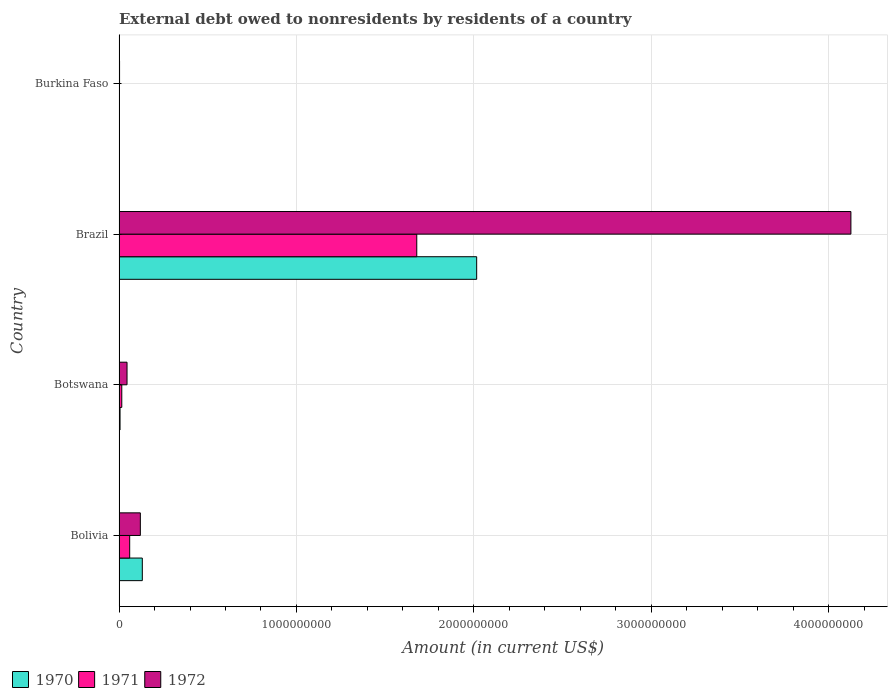How many different coloured bars are there?
Offer a very short reply. 3. Are the number of bars on each tick of the Y-axis equal?
Give a very brief answer. Yes. How many bars are there on the 3rd tick from the bottom?
Give a very brief answer. 3. What is the label of the 4th group of bars from the top?
Give a very brief answer. Bolivia. What is the external debt owed by residents in 1970 in Bolivia?
Provide a succinct answer. 1.31e+08. Across all countries, what is the maximum external debt owed by residents in 1970?
Keep it short and to the point. 2.02e+09. Across all countries, what is the minimum external debt owed by residents in 1971?
Offer a terse response. 1.32e+06. In which country was the external debt owed by residents in 1971 maximum?
Make the answer very short. Brazil. In which country was the external debt owed by residents in 1970 minimum?
Give a very brief answer. Burkina Faso. What is the total external debt owed by residents in 1972 in the graph?
Offer a terse response. 4.29e+09. What is the difference between the external debt owed by residents in 1970 in Bolivia and that in Burkina Faso?
Your answer should be compact. 1.30e+08. What is the difference between the external debt owed by residents in 1971 in Bolivia and the external debt owed by residents in 1972 in Botswana?
Provide a succinct answer. 1.50e+07. What is the average external debt owed by residents in 1972 per country?
Your answer should be compact. 1.07e+09. What is the difference between the external debt owed by residents in 1970 and external debt owed by residents in 1971 in Burkina Faso?
Offer a terse response. -6.68e+05. What is the ratio of the external debt owed by residents in 1971 in Botswana to that in Burkina Faso?
Ensure brevity in your answer.  11.67. Is the difference between the external debt owed by residents in 1970 in Bolivia and Burkina Faso greater than the difference between the external debt owed by residents in 1971 in Bolivia and Burkina Faso?
Keep it short and to the point. Yes. What is the difference between the highest and the second highest external debt owed by residents in 1972?
Give a very brief answer. 4.00e+09. What is the difference between the highest and the lowest external debt owed by residents in 1971?
Keep it short and to the point. 1.68e+09. Is the sum of the external debt owed by residents in 1970 in Botswana and Burkina Faso greater than the maximum external debt owed by residents in 1972 across all countries?
Make the answer very short. No. What does the 1st bar from the top in Brazil represents?
Give a very brief answer. 1972. How many bars are there?
Offer a terse response. 12. What is the difference between two consecutive major ticks on the X-axis?
Give a very brief answer. 1.00e+09. Are the values on the major ticks of X-axis written in scientific E-notation?
Your answer should be very brief. No. Does the graph contain grids?
Provide a short and direct response. Yes. What is the title of the graph?
Your response must be concise. External debt owed to nonresidents by residents of a country. Does "1963" appear as one of the legend labels in the graph?
Make the answer very short. No. What is the label or title of the X-axis?
Your response must be concise. Amount (in current US$). What is the label or title of the Y-axis?
Provide a succinct answer. Country. What is the Amount (in current US$) of 1970 in Bolivia?
Keep it short and to the point. 1.31e+08. What is the Amount (in current US$) in 1971 in Bolivia?
Give a very brief answer. 5.99e+07. What is the Amount (in current US$) in 1972 in Bolivia?
Give a very brief answer. 1.20e+08. What is the Amount (in current US$) in 1970 in Botswana?
Ensure brevity in your answer.  5.57e+06. What is the Amount (in current US$) of 1971 in Botswana?
Provide a short and direct response. 1.54e+07. What is the Amount (in current US$) of 1972 in Botswana?
Keep it short and to the point. 4.50e+07. What is the Amount (in current US$) in 1970 in Brazil?
Your answer should be compact. 2.02e+09. What is the Amount (in current US$) in 1971 in Brazil?
Give a very brief answer. 1.68e+09. What is the Amount (in current US$) in 1972 in Brazil?
Your answer should be compact. 4.13e+09. What is the Amount (in current US$) of 1970 in Burkina Faso?
Offer a very short reply. 6.51e+05. What is the Amount (in current US$) of 1971 in Burkina Faso?
Provide a short and direct response. 1.32e+06. What is the Amount (in current US$) in 1972 in Burkina Faso?
Make the answer very short. 2.91e+06. Across all countries, what is the maximum Amount (in current US$) of 1970?
Provide a succinct answer. 2.02e+09. Across all countries, what is the maximum Amount (in current US$) of 1971?
Provide a short and direct response. 1.68e+09. Across all countries, what is the maximum Amount (in current US$) of 1972?
Provide a short and direct response. 4.13e+09. Across all countries, what is the minimum Amount (in current US$) in 1970?
Offer a very short reply. 6.51e+05. Across all countries, what is the minimum Amount (in current US$) of 1971?
Your response must be concise. 1.32e+06. Across all countries, what is the minimum Amount (in current US$) of 1972?
Give a very brief answer. 2.91e+06. What is the total Amount (in current US$) of 1970 in the graph?
Offer a very short reply. 2.15e+09. What is the total Amount (in current US$) of 1971 in the graph?
Your response must be concise. 1.75e+09. What is the total Amount (in current US$) of 1972 in the graph?
Keep it short and to the point. 4.29e+09. What is the difference between the Amount (in current US$) in 1970 in Bolivia and that in Botswana?
Ensure brevity in your answer.  1.26e+08. What is the difference between the Amount (in current US$) in 1971 in Bolivia and that in Botswana?
Provide a short and direct response. 4.45e+07. What is the difference between the Amount (in current US$) of 1972 in Bolivia and that in Botswana?
Ensure brevity in your answer.  7.51e+07. What is the difference between the Amount (in current US$) in 1970 in Bolivia and that in Brazil?
Ensure brevity in your answer.  -1.88e+09. What is the difference between the Amount (in current US$) of 1971 in Bolivia and that in Brazil?
Give a very brief answer. -1.62e+09. What is the difference between the Amount (in current US$) of 1972 in Bolivia and that in Brazil?
Offer a very short reply. -4.00e+09. What is the difference between the Amount (in current US$) of 1970 in Bolivia and that in Burkina Faso?
Keep it short and to the point. 1.30e+08. What is the difference between the Amount (in current US$) in 1971 in Bolivia and that in Burkina Faso?
Keep it short and to the point. 5.86e+07. What is the difference between the Amount (in current US$) of 1972 in Bolivia and that in Burkina Faso?
Provide a short and direct response. 1.17e+08. What is the difference between the Amount (in current US$) in 1970 in Botswana and that in Brazil?
Offer a terse response. -2.01e+09. What is the difference between the Amount (in current US$) of 1971 in Botswana and that in Brazil?
Make the answer very short. -1.66e+09. What is the difference between the Amount (in current US$) in 1972 in Botswana and that in Brazil?
Your answer should be compact. -4.08e+09. What is the difference between the Amount (in current US$) of 1970 in Botswana and that in Burkina Faso?
Keep it short and to the point. 4.92e+06. What is the difference between the Amount (in current US$) in 1971 in Botswana and that in Burkina Faso?
Ensure brevity in your answer.  1.41e+07. What is the difference between the Amount (in current US$) of 1972 in Botswana and that in Burkina Faso?
Keep it short and to the point. 4.20e+07. What is the difference between the Amount (in current US$) of 1970 in Brazil and that in Burkina Faso?
Provide a succinct answer. 2.02e+09. What is the difference between the Amount (in current US$) in 1971 in Brazil and that in Burkina Faso?
Provide a succinct answer. 1.68e+09. What is the difference between the Amount (in current US$) in 1972 in Brazil and that in Burkina Faso?
Provide a succinct answer. 4.12e+09. What is the difference between the Amount (in current US$) of 1970 in Bolivia and the Amount (in current US$) of 1971 in Botswana?
Your answer should be compact. 1.16e+08. What is the difference between the Amount (in current US$) of 1970 in Bolivia and the Amount (in current US$) of 1972 in Botswana?
Keep it short and to the point. 8.61e+07. What is the difference between the Amount (in current US$) of 1971 in Bolivia and the Amount (in current US$) of 1972 in Botswana?
Ensure brevity in your answer.  1.50e+07. What is the difference between the Amount (in current US$) of 1970 in Bolivia and the Amount (in current US$) of 1971 in Brazil?
Provide a succinct answer. -1.55e+09. What is the difference between the Amount (in current US$) in 1970 in Bolivia and the Amount (in current US$) in 1972 in Brazil?
Your answer should be very brief. -3.99e+09. What is the difference between the Amount (in current US$) in 1971 in Bolivia and the Amount (in current US$) in 1972 in Brazil?
Offer a very short reply. -4.07e+09. What is the difference between the Amount (in current US$) in 1970 in Bolivia and the Amount (in current US$) in 1971 in Burkina Faso?
Your answer should be compact. 1.30e+08. What is the difference between the Amount (in current US$) of 1970 in Bolivia and the Amount (in current US$) of 1972 in Burkina Faso?
Offer a very short reply. 1.28e+08. What is the difference between the Amount (in current US$) in 1971 in Bolivia and the Amount (in current US$) in 1972 in Burkina Faso?
Your response must be concise. 5.70e+07. What is the difference between the Amount (in current US$) of 1970 in Botswana and the Amount (in current US$) of 1971 in Brazil?
Your response must be concise. -1.67e+09. What is the difference between the Amount (in current US$) in 1970 in Botswana and the Amount (in current US$) in 1972 in Brazil?
Give a very brief answer. -4.12e+09. What is the difference between the Amount (in current US$) of 1971 in Botswana and the Amount (in current US$) of 1972 in Brazil?
Make the answer very short. -4.11e+09. What is the difference between the Amount (in current US$) of 1970 in Botswana and the Amount (in current US$) of 1971 in Burkina Faso?
Your answer should be compact. 4.25e+06. What is the difference between the Amount (in current US$) in 1970 in Botswana and the Amount (in current US$) in 1972 in Burkina Faso?
Your response must be concise. 2.66e+06. What is the difference between the Amount (in current US$) of 1971 in Botswana and the Amount (in current US$) of 1972 in Burkina Faso?
Ensure brevity in your answer.  1.25e+07. What is the difference between the Amount (in current US$) of 1970 in Brazil and the Amount (in current US$) of 1971 in Burkina Faso?
Provide a succinct answer. 2.01e+09. What is the difference between the Amount (in current US$) in 1970 in Brazil and the Amount (in current US$) in 1972 in Burkina Faso?
Ensure brevity in your answer.  2.01e+09. What is the difference between the Amount (in current US$) in 1971 in Brazil and the Amount (in current US$) in 1972 in Burkina Faso?
Make the answer very short. 1.68e+09. What is the average Amount (in current US$) of 1970 per country?
Make the answer very short. 5.38e+08. What is the average Amount (in current US$) in 1971 per country?
Provide a short and direct response. 4.39e+08. What is the average Amount (in current US$) of 1972 per country?
Your answer should be compact. 1.07e+09. What is the difference between the Amount (in current US$) of 1970 and Amount (in current US$) of 1971 in Bolivia?
Your response must be concise. 7.11e+07. What is the difference between the Amount (in current US$) of 1970 and Amount (in current US$) of 1972 in Bolivia?
Your answer should be very brief. 1.10e+07. What is the difference between the Amount (in current US$) of 1971 and Amount (in current US$) of 1972 in Bolivia?
Offer a very short reply. -6.01e+07. What is the difference between the Amount (in current US$) in 1970 and Amount (in current US$) in 1971 in Botswana?
Ensure brevity in your answer.  -9.82e+06. What is the difference between the Amount (in current US$) of 1970 and Amount (in current US$) of 1972 in Botswana?
Ensure brevity in your answer.  -3.94e+07. What is the difference between the Amount (in current US$) in 1971 and Amount (in current US$) in 1972 in Botswana?
Give a very brief answer. -2.96e+07. What is the difference between the Amount (in current US$) in 1970 and Amount (in current US$) in 1971 in Brazil?
Provide a succinct answer. 3.38e+08. What is the difference between the Amount (in current US$) in 1970 and Amount (in current US$) in 1972 in Brazil?
Ensure brevity in your answer.  -2.11e+09. What is the difference between the Amount (in current US$) of 1971 and Amount (in current US$) of 1972 in Brazil?
Provide a short and direct response. -2.45e+09. What is the difference between the Amount (in current US$) in 1970 and Amount (in current US$) in 1971 in Burkina Faso?
Make the answer very short. -6.68e+05. What is the difference between the Amount (in current US$) of 1970 and Amount (in current US$) of 1972 in Burkina Faso?
Your answer should be very brief. -2.26e+06. What is the difference between the Amount (in current US$) in 1971 and Amount (in current US$) in 1972 in Burkina Faso?
Your response must be concise. -1.59e+06. What is the ratio of the Amount (in current US$) of 1970 in Bolivia to that in Botswana?
Your answer should be compact. 23.55. What is the ratio of the Amount (in current US$) in 1971 in Bolivia to that in Botswana?
Offer a terse response. 3.89. What is the ratio of the Amount (in current US$) of 1972 in Bolivia to that in Botswana?
Keep it short and to the point. 2.67. What is the ratio of the Amount (in current US$) of 1970 in Bolivia to that in Brazil?
Your answer should be very brief. 0.07. What is the ratio of the Amount (in current US$) of 1971 in Bolivia to that in Brazil?
Your answer should be compact. 0.04. What is the ratio of the Amount (in current US$) of 1972 in Bolivia to that in Brazil?
Provide a succinct answer. 0.03. What is the ratio of the Amount (in current US$) of 1970 in Bolivia to that in Burkina Faso?
Offer a very short reply. 201.34. What is the ratio of the Amount (in current US$) in 1971 in Bolivia to that in Burkina Faso?
Ensure brevity in your answer.  45.43. What is the ratio of the Amount (in current US$) of 1972 in Bolivia to that in Burkina Faso?
Make the answer very short. 41.31. What is the ratio of the Amount (in current US$) of 1970 in Botswana to that in Brazil?
Offer a terse response. 0. What is the ratio of the Amount (in current US$) of 1971 in Botswana to that in Brazil?
Give a very brief answer. 0.01. What is the ratio of the Amount (in current US$) of 1972 in Botswana to that in Brazil?
Keep it short and to the point. 0.01. What is the ratio of the Amount (in current US$) in 1970 in Botswana to that in Burkina Faso?
Provide a succinct answer. 8.55. What is the ratio of the Amount (in current US$) of 1971 in Botswana to that in Burkina Faso?
Provide a succinct answer. 11.67. What is the ratio of the Amount (in current US$) of 1972 in Botswana to that in Burkina Faso?
Offer a terse response. 15.47. What is the ratio of the Amount (in current US$) of 1970 in Brazil to that in Burkina Faso?
Ensure brevity in your answer.  3096.3. What is the ratio of the Amount (in current US$) in 1971 in Brazil to that in Burkina Faso?
Your answer should be very brief. 1272.21. What is the ratio of the Amount (in current US$) of 1972 in Brazil to that in Burkina Faso?
Your answer should be very brief. 1419.49. What is the difference between the highest and the second highest Amount (in current US$) in 1970?
Offer a very short reply. 1.88e+09. What is the difference between the highest and the second highest Amount (in current US$) of 1971?
Your response must be concise. 1.62e+09. What is the difference between the highest and the second highest Amount (in current US$) in 1972?
Provide a succinct answer. 4.00e+09. What is the difference between the highest and the lowest Amount (in current US$) in 1970?
Provide a succinct answer. 2.02e+09. What is the difference between the highest and the lowest Amount (in current US$) in 1971?
Make the answer very short. 1.68e+09. What is the difference between the highest and the lowest Amount (in current US$) in 1972?
Provide a short and direct response. 4.12e+09. 